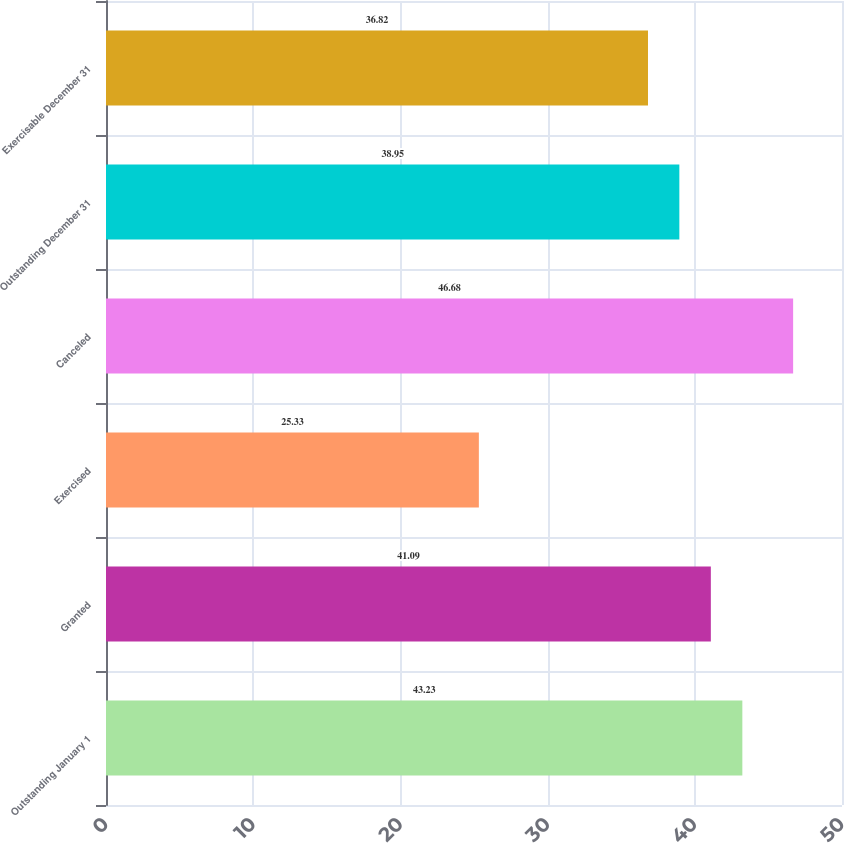Convert chart to OTSL. <chart><loc_0><loc_0><loc_500><loc_500><bar_chart><fcel>Outstanding January 1<fcel>Granted<fcel>Exercised<fcel>Canceled<fcel>Outstanding December 31<fcel>Exercisable December 31<nl><fcel>43.23<fcel>41.09<fcel>25.33<fcel>46.68<fcel>38.95<fcel>36.82<nl></chart> 